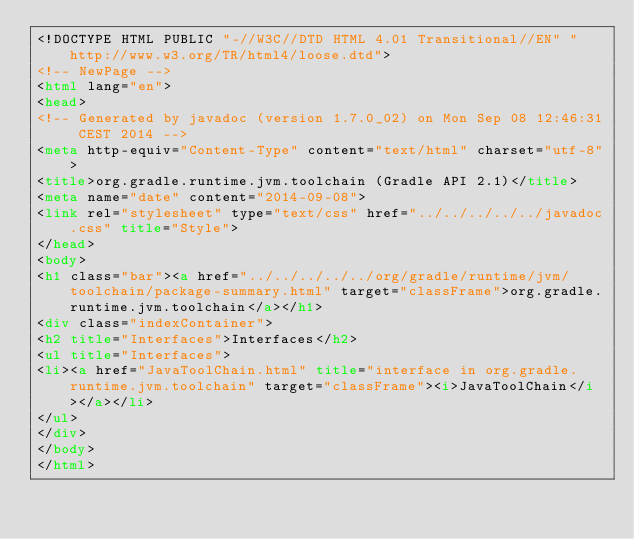<code> <loc_0><loc_0><loc_500><loc_500><_HTML_><!DOCTYPE HTML PUBLIC "-//W3C//DTD HTML 4.01 Transitional//EN" "http://www.w3.org/TR/html4/loose.dtd">
<!-- NewPage -->
<html lang="en">
<head>
<!-- Generated by javadoc (version 1.7.0_02) on Mon Sep 08 12:46:31 CEST 2014 -->
<meta http-equiv="Content-Type" content="text/html" charset="utf-8">
<title>org.gradle.runtime.jvm.toolchain (Gradle API 2.1)</title>
<meta name="date" content="2014-09-08">
<link rel="stylesheet" type="text/css" href="../../../../../javadoc.css" title="Style">
</head>
<body>
<h1 class="bar"><a href="../../../../../org/gradle/runtime/jvm/toolchain/package-summary.html" target="classFrame">org.gradle.runtime.jvm.toolchain</a></h1>
<div class="indexContainer">
<h2 title="Interfaces">Interfaces</h2>
<ul title="Interfaces">
<li><a href="JavaToolChain.html" title="interface in org.gradle.runtime.jvm.toolchain" target="classFrame"><i>JavaToolChain</i></a></li>
</ul>
</div>
</body>
</html>
</code> 